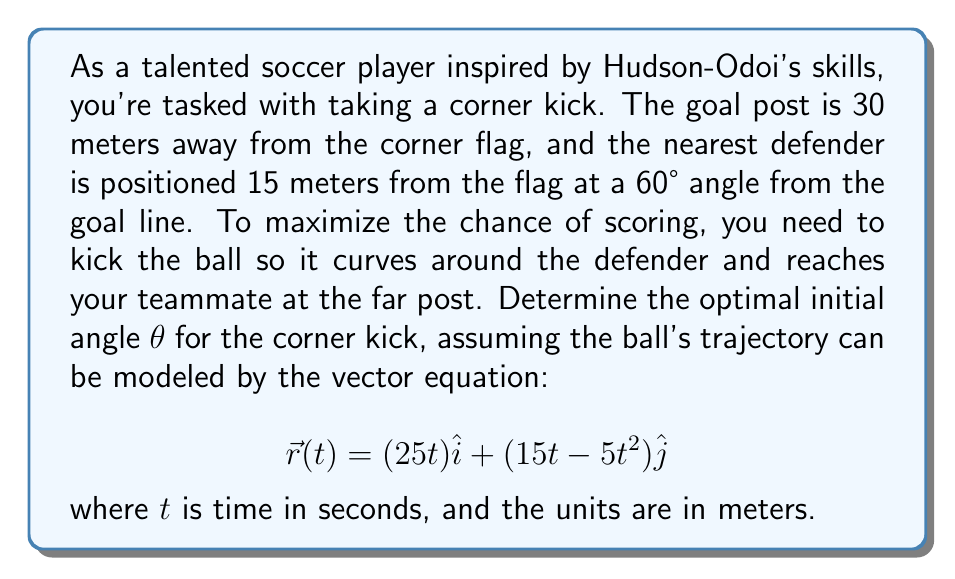Can you solve this math problem? To solve this problem, we'll follow these steps:

1) First, let's visualize the scenario:

[asy]
import geometry;

unitsize(5mm);
draw((0,0)--(30,0), arrow=Arrow(TeXHead));
draw((0,0)--(0,30), arrow=Arrow(TeXHead));
draw((0,0)--(30,30), dashed);
draw((0,0)--(15*cos(60°),15*sin(60°)), red);
dot((30,30));
dot((0,0));
dot((15*cos(60°),15*sin(60°)), red);
label("Goal post", (30,30), NE);
label("Corner flag", (0,0), SW);
label("Defender", (15*cos(60°),15*sin(60°)), NE);
label("θ", (2,0), N);
label("x", (30,0), S);
label("y", (0,30), W);
[/asy]

2) The vector equation gives us the x and y components of the ball's position at any time t:

   $x(t) = 25t$
   $y(t) = 15t - 5t^2$

3) To find the initial angle θ, we need to calculate the velocity vector at t = 0:

   $\vec{v}(0) = \frac{d\vec{r}}{dt}(0) = (25)\hat{i} + (15)\hat{j}$

4) The angle θ is the arctangent of the ratio of y-component to x-component of the initial velocity:

   $θ = \arctan(\frac{v_y}{v_x}) = \arctan(\frac{15}{25})$

5) Calculate the angle:

   $θ = \arctan(0.6) \approx 30.96°$

6) To verify if this angle is optimal, we should check if the ball clears the defender. The defender is at (15cos(60°), 15sin(60°)) ≈ (7.5, 13.0) meters.

7) Solve for t when x = 7.5 meters:

   $7.5 = 25t$
   $t = 0.3$ seconds

8) At t = 0.3 seconds, the y-coordinate of the ball is:

   $y(0.3) = 15(0.3) - 5(0.3)^2 = 4.5 - 0.45 = 4.05$ meters

9) Since 4.05 meters < 13.0 meters, the ball passes under the defender, making this a valid trajectory.
Answer: The optimal initial angle for the corner kick is approximately $30.96°$. 